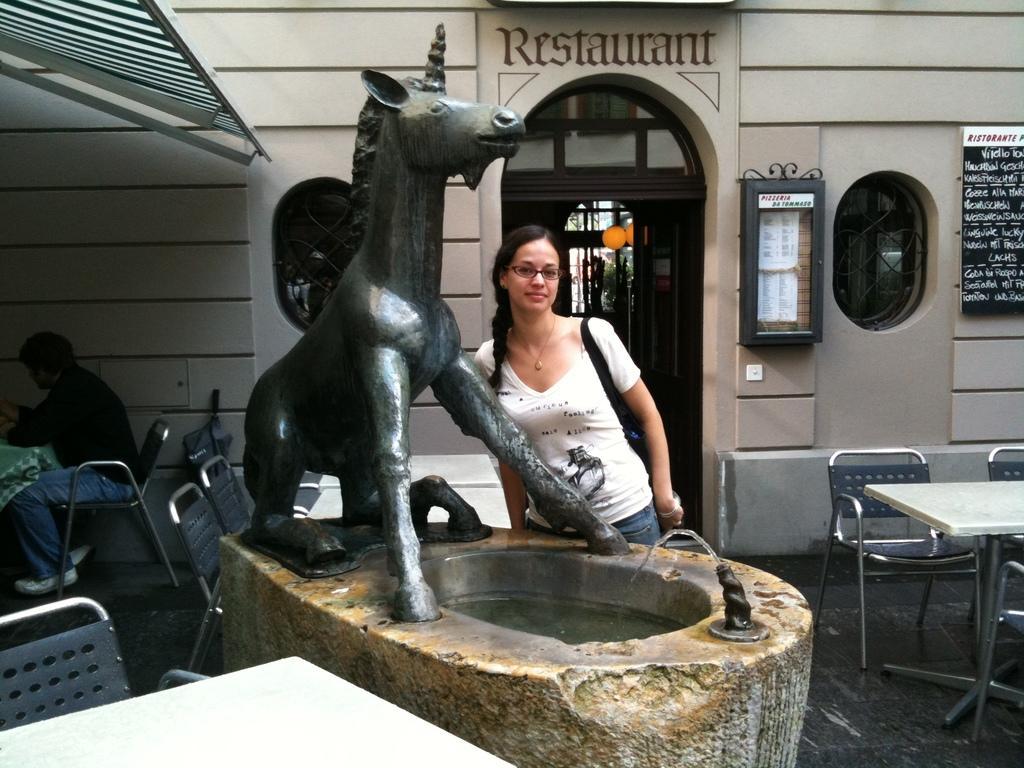Describe this image in one or two sentences. The image is outside of the city. In the image there is a woman standing in front of a statue. On left side there is another man sitting on chair in front of a table, on right side there is a black color hoarding in middle there is a door which is closed. In background there is a wall on which it is written as 'RESTAURANT' and it is also in cream color. 